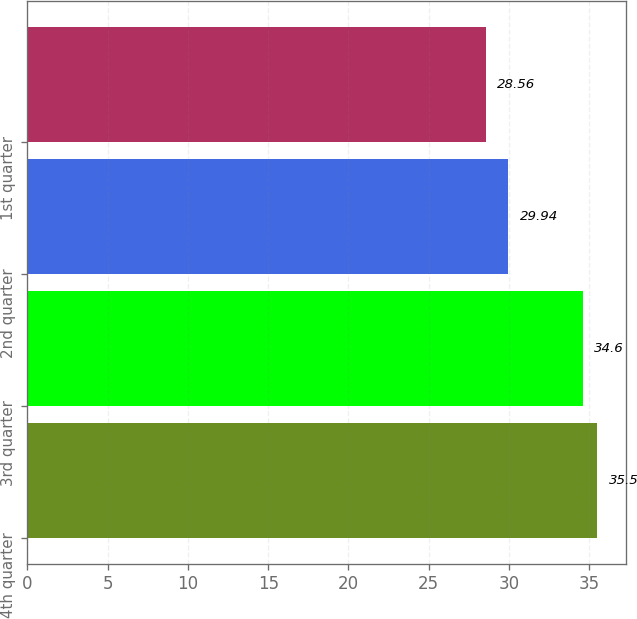Convert chart to OTSL. <chart><loc_0><loc_0><loc_500><loc_500><bar_chart><fcel>4th quarter<fcel>3rd quarter<fcel>2nd quarter<fcel>1st quarter<nl><fcel>35.5<fcel>34.6<fcel>29.94<fcel>28.56<nl></chart> 